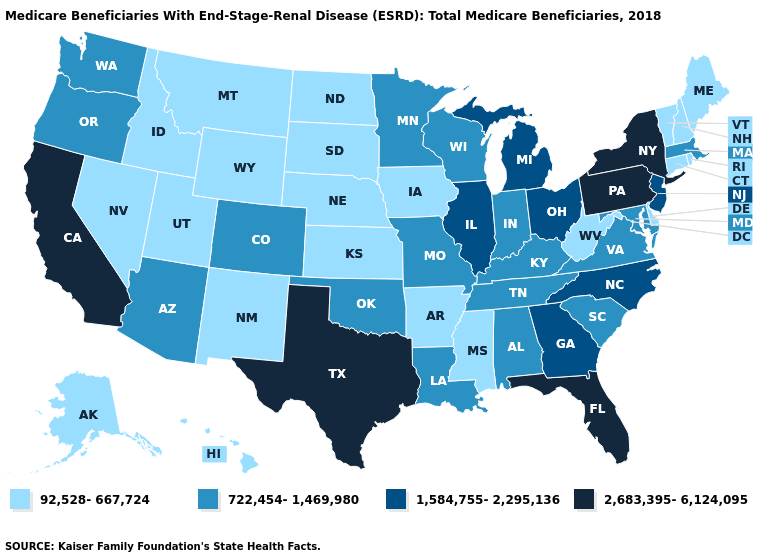Does Idaho have the highest value in the USA?
Concise answer only. No. What is the highest value in states that border Louisiana?
Concise answer only. 2,683,395-6,124,095. Name the states that have a value in the range 92,528-667,724?
Short answer required. Alaska, Arkansas, Connecticut, Delaware, Hawaii, Idaho, Iowa, Kansas, Maine, Mississippi, Montana, Nebraska, Nevada, New Hampshire, New Mexico, North Dakota, Rhode Island, South Dakota, Utah, Vermont, West Virginia, Wyoming. What is the value of North Carolina?
Concise answer only. 1,584,755-2,295,136. What is the value of Ohio?
Write a very short answer. 1,584,755-2,295,136. What is the value of Connecticut?
Give a very brief answer. 92,528-667,724. Which states have the highest value in the USA?
Concise answer only. California, Florida, New York, Pennsylvania, Texas. Among the states that border Nevada , which have the lowest value?
Give a very brief answer. Idaho, Utah. Among the states that border Minnesota , which have the lowest value?
Concise answer only. Iowa, North Dakota, South Dakota. Does the first symbol in the legend represent the smallest category?
Give a very brief answer. Yes. What is the lowest value in the USA?
Quick response, please. 92,528-667,724. Does Oklahoma have a higher value than Alaska?
Write a very short answer. Yes. What is the value of Nevada?
Give a very brief answer. 92,528-667,724. Does New Hampshire have the lowest value in the Northeast?
Give a very brief answer. Yes. Is the legend a continuous bar?
Write a very short answer. No. 